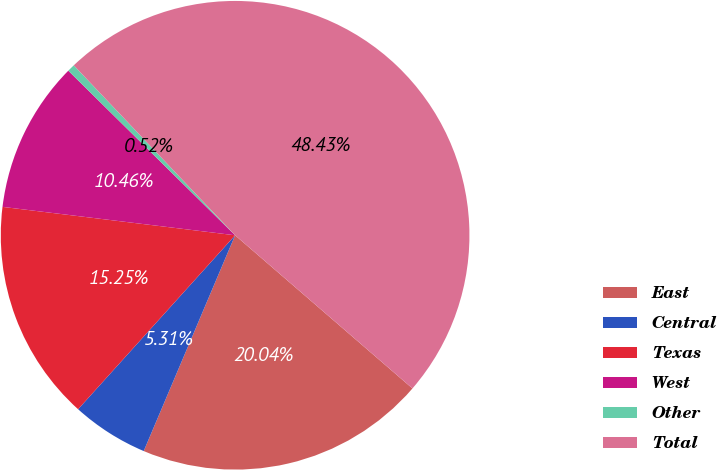Convert chart. <chart><loc_0><loc_0><loc_500><loc_500><pie_chart><fcel>East<fcel>Central<fcel>Texas<fcel>West<fcel>Other<fcel>Total<nl><fcel>20.04%<fcel>5.31%<fcel>15.25%<fcel>10.46%<fcel>0.52%<fcel>48.43%<nl></chart> 